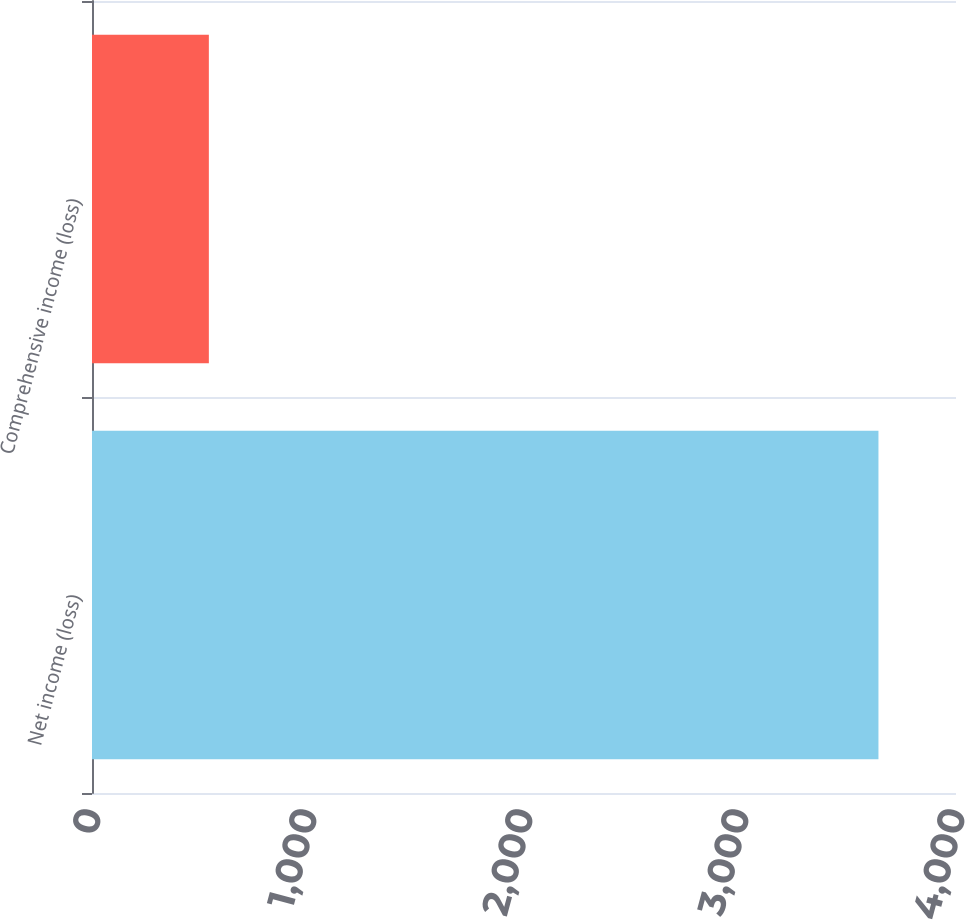<chart> <loc_0><loc_0><loc_500><loc_500><bar_chart><fcel>Net income (loss)<fcel>Comprehensive income (loss)<nl><fcel>3641<fcel>541<nl></chart> 